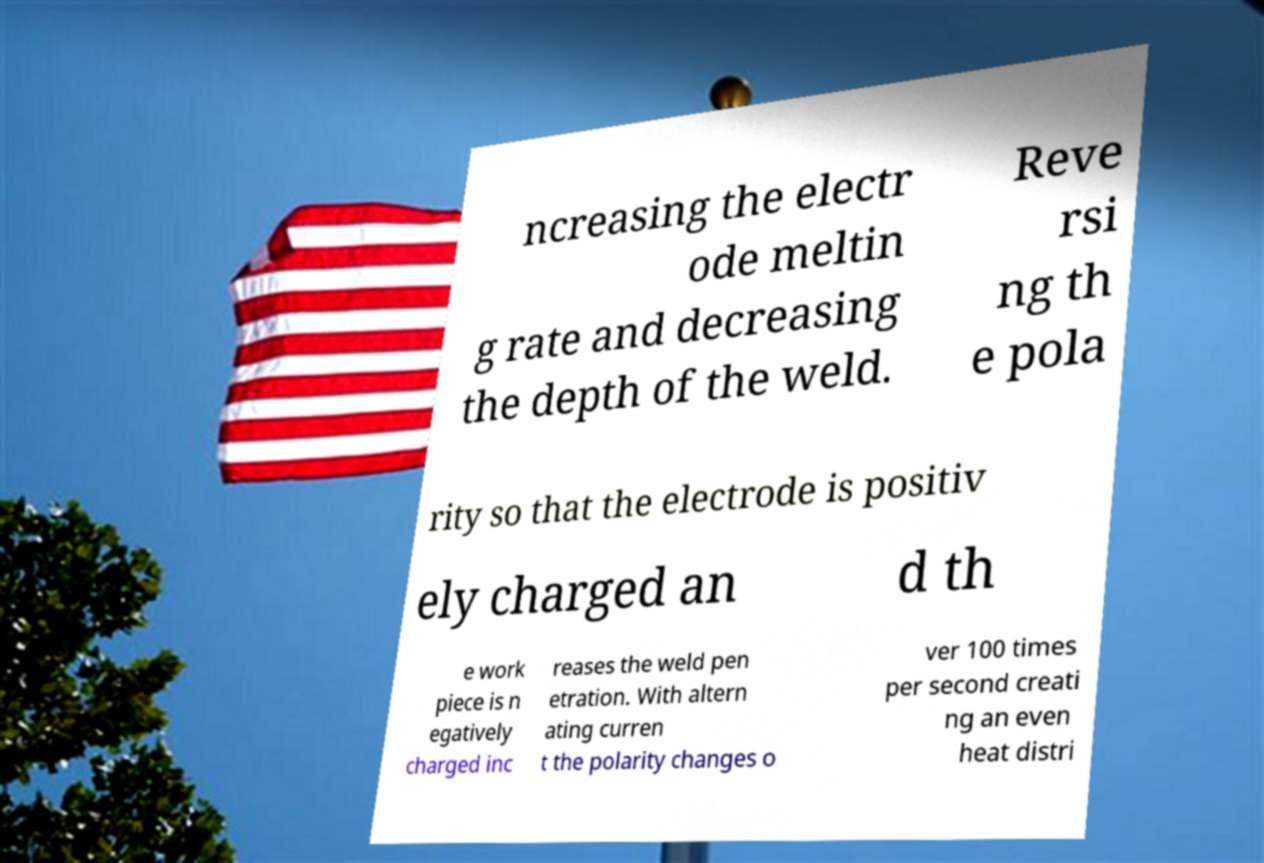Please read and relay the text visible in this image. What does it say? ncreasing the electr ode meltin g rate and decreasing the depth of the weld. Reve rsi ng th e pola rity so that the electrode is positiv ely charged an d th e work piece is n egatively charged inc reases the weld pen etration. With altern ating curren t the polarity changes o ver 100 times per second creati ng an even heat distri 